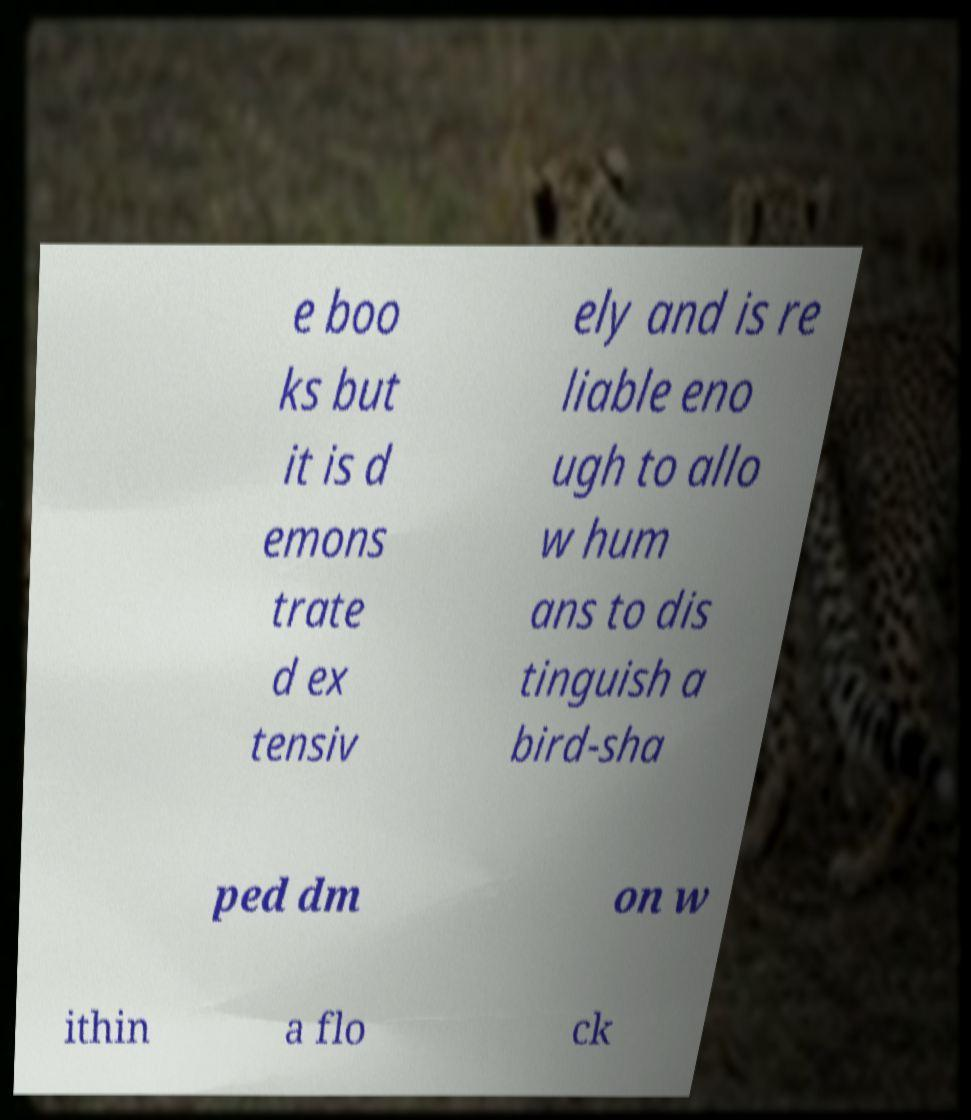Please identify and transcribe the text found in this image. e boo ks but it is d emons trate d ex tensiv ely and is re liable eno ugh to allo w hum ans to dis tinguish a bird-sha ped dm on w ithin a flo ck 